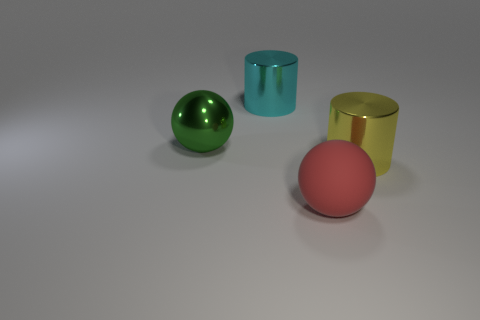Are there more yellow things than big blue things?
Make the answer very short. Yes. There is a big cyan metallic object that is to the left of the big metal cylinder right of the large matte object; what shape is it?
Make the answer very short. Cylinder. Are there any cyan cylinders that are behind the sphere that is on the left side of the cylinder left of the yellow object?
Provide a succinct answer. Yes. What is the color of the rubber ball that is the same size as the yellow cylinder?
Offer a terse response. Red. There is a large shiny object that is to the right of the large green sphere and behind the big yellow metallic cylinder; what shape is it?
Give a very brief answer. Cylinder. What is the size of the green shiny thing that is behind the cylinder in front of the cyan shiny thing?
Keep it short and to the point. Large. How many big objects have the same color as the matte sphere?
Your answer should be very brief. 0. What number of other red objects are the same shape as the big red matte thing?
Make the answer very short. 0. What is the big green object made of?
Keep it short and to the point. Metal. Do the yellow metal object and the cyan metal object have the same shape?
Offer a terse response. Yes. 